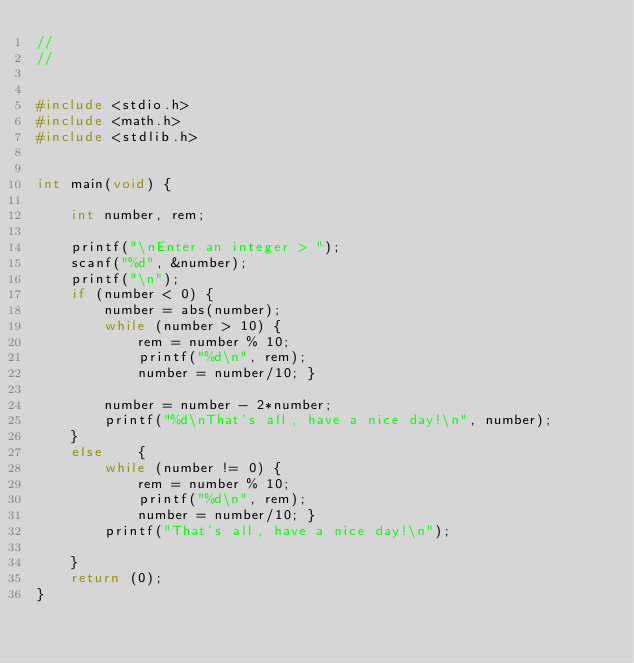Convert code to text. <code><loc_0><loc_0><loc_500><loc_500><_C_>//
//


#include <stdio.h>
#include <math.h>
#include <stdlib.h>
	

int main(void) {

	int number, rem;
	
	printf("\nEnter an integer > ");
	scanf("%d", &number);
	printf("\n");
	if (number < 0) {
		number = abs(number);
		while (number > 10) {
			rem = number % 10;
			printf("%d\n", rem);
			number = number/10; }
		
		number = number - 2*number;
		printf("%d\nThat's all, have a nice day!\n", number);
	}
	else	{
		while (number != 0) {
			rem = number % 10;
			printf("%d\n", rem);
			number = number/10; }
		printf("That's all, have a nice day!\n");

	}
	return (0);
} 
</code> 